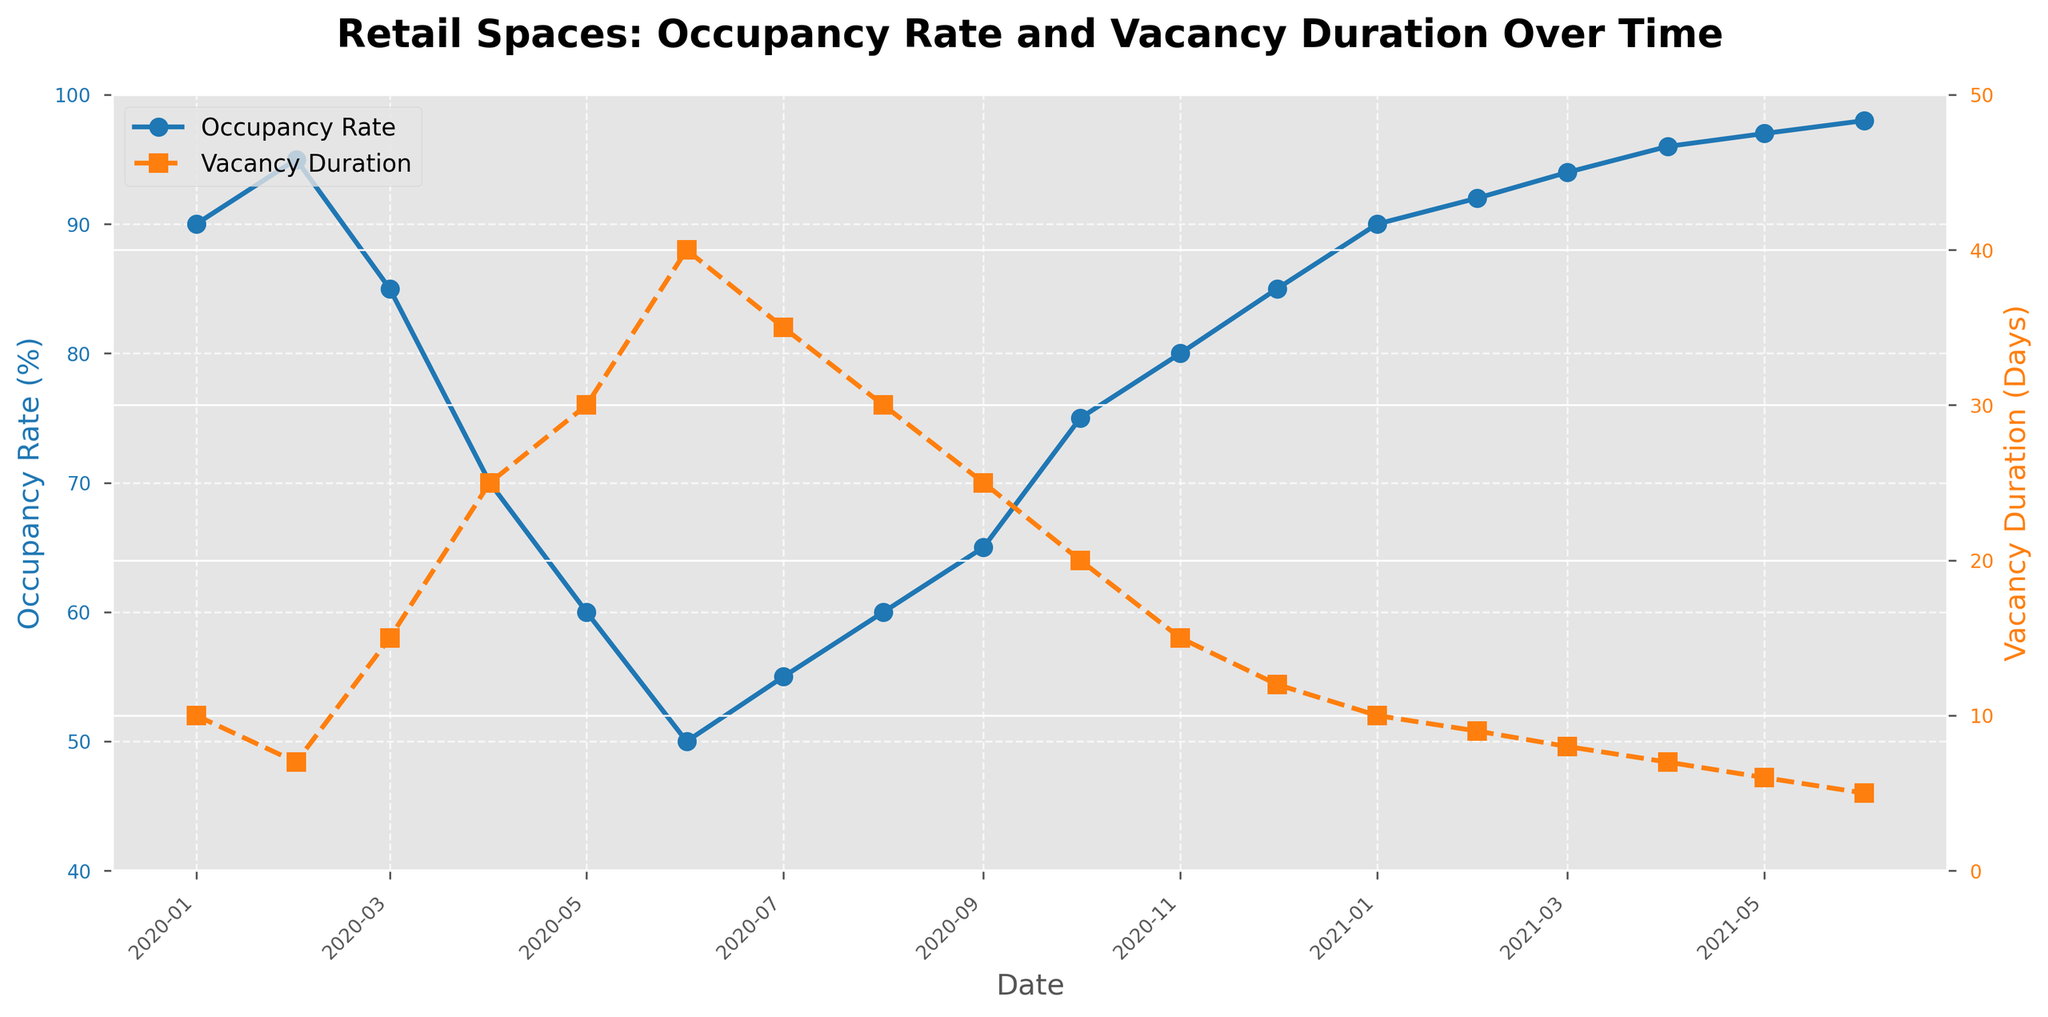what is the title of the figure? The title is displayed at the top of the figure. It is 'Retail Spaces: Occupancy Rate and Vacancy Duration Over Time'.
Answer: Retail Spaces: Occupancy Rate and Vacancy Duration Over Time How many data points are shown in the time series plot? Count the number of markers on either the Occupancy Rate or Vacancy Duration plots. There are 18 date points.
Answer: 18 What are the colors used for the Occupancy Rate and Vacancy Duration lines? Look at the legend and the lines in the plot. Occupancy Rate is in blue, and Vacancy Duration is in orange.
Answer: blue, orange In which month and year did the Occupancy Rate reach its lowest value? Identify the lowest point on the Occupancy Rate line, which is around mid-2020, specifically June 2020.
Answer: June 2020 At what value did the Vacancy Duration peak, and in which month? Locate the peak value on the Vacancy Duration line, which happens in June 2020 and is 40 days.
Answer: 40 days, June 2020 Which period observed a consistent increase in the Occupancy Rate over multiple months? Identify the stretch on the Occupancy Rate line where there's a continuous upward trend, which is from July 2020 to June 2021.
Answer: July 2020 to June 2021 Between January 2020 and June 2020, how did the Occupancy Rate change? Find the values of Occupancy Rate in January 2020 (90%) and June 2020 (50%). Calculate the difference: 90% - 50% = 40%.
Answer: Decreased by 40% During the same period, how much did the Vacancy Duration change? Find the values of Vacancy Duration in January 2020 (10 days) and June 2020 (40 days). Calculate the difference: 40 days - 10 days = 30 days.
Answer: Increased by 30 days Which date has the closest Occupancy Rate to 75% and what is the corresponding Vacancy Duration? Look on the Occupancy Rate plot for the closest point to 75%, which is October 2020, with a corresponding Vacancy Duration of 20 days.
Answer: October 2020, 20 days Does the Occupancy Rate generally inversely correlate with Vacancy Duration over the observed period? Check the general trends of the two lines: Occupancy Rate decreases are generally accompanied by increases in Vacancy Duration and vice versa.
Answer: Yes 